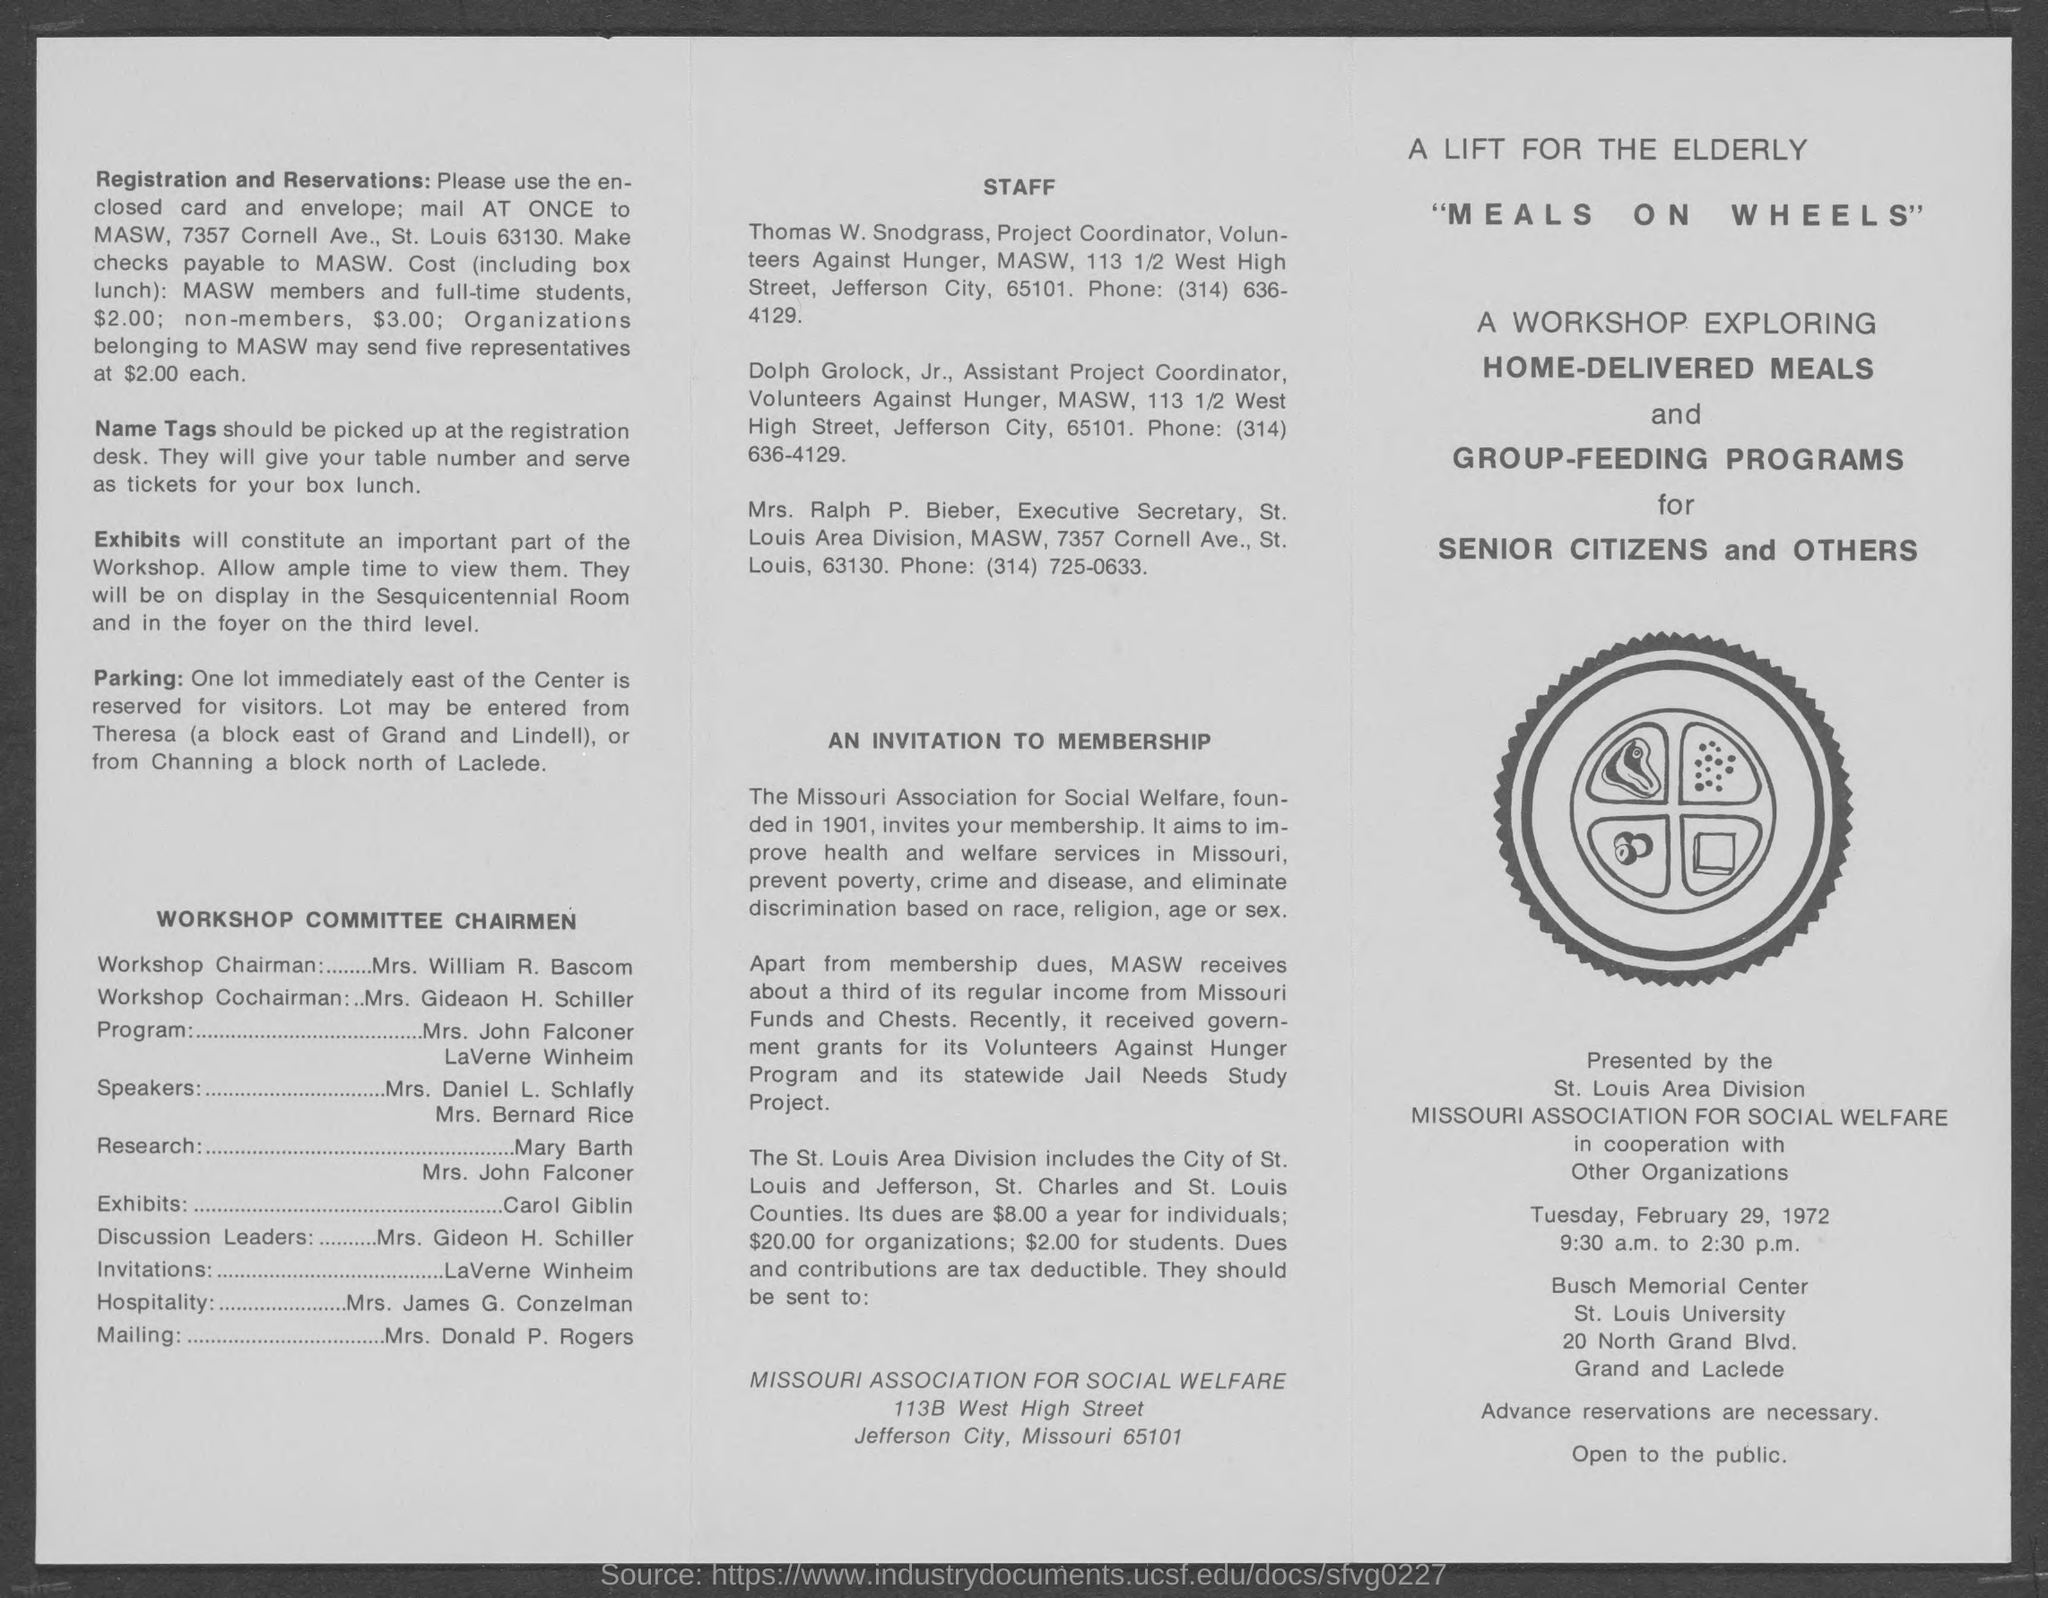Mention a couple of crucial points in this snapshot. To whom should checks be payable? The answer is clear: MASW. The workshop chairman is Mrs. William R. Bascom. Mrs. Donald P. Rogers' duty is to mail. The workshop will take place from 9:30 a.m. to 2:30 p.m. Carol Giblin is in charge of the exhibits. 